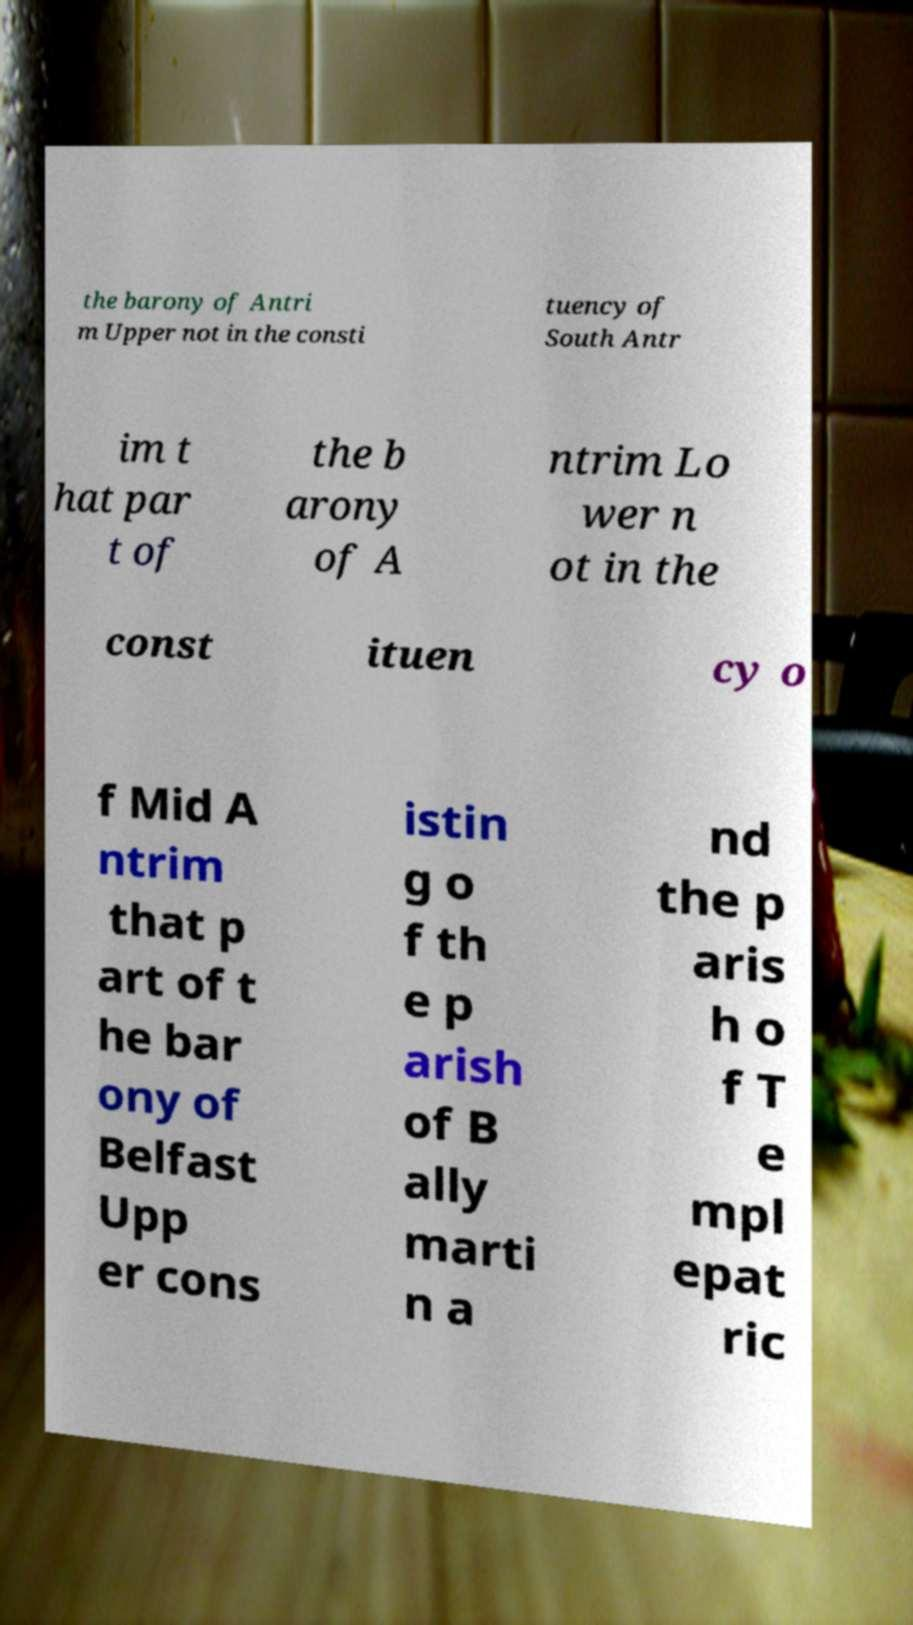Could you assist in decoding the text presented in this image and type it out clearly? the barony of Antri m Upper not in the consti tuency of South Antr im t hat par t of the b arony of A ntrim Lo wer n ot in the const ituen cy o f Mid A ntrim that p art of t he bar ony of Belfast Upp er cons istin g o f th e p arish of B ally marti n a nd the p aris h o f T e mpl epat ric 